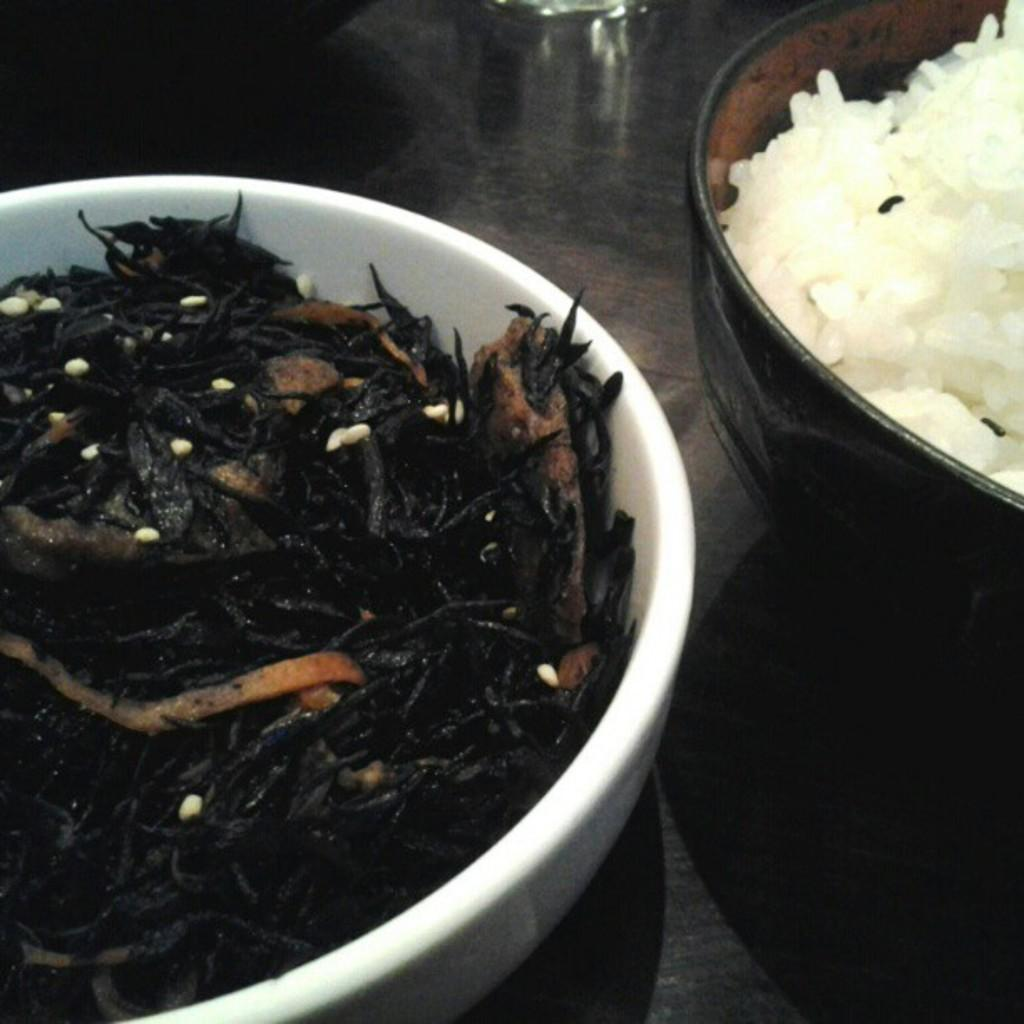What can be seen in the image related to food? There are two food items in the image, and they are in two separate bowls. Can you describe the glass object on the table? There is a glass object on the table, but its specific purpose or appearance is not mentioned in the facts. How many bowls are present in the image? There are two bowls present in the image, each containing a food item. What language is being spoken by the sister in the image? There is no mention of a sister or any spoken language in the image or the provided facts. 